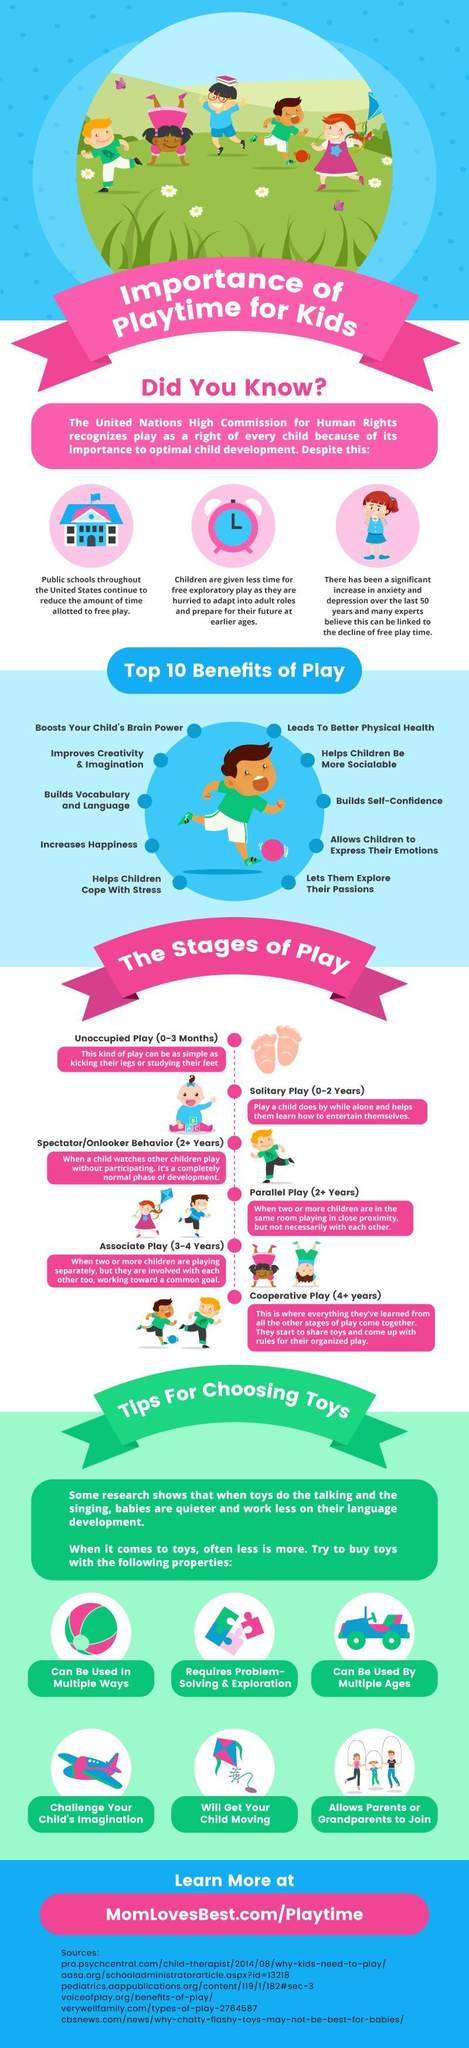What is mentioned as the fourth stage of play?
Answer the question with a short phrase. Parallel play (2+ years) What might be a reason for increase in anxiety and depression in children? decline of free play time How many stages of play are mentioned in this graphic? 6 What is the second stage of play mentioned? Solitary Play (0-2 years) What helps children be more sociable? Play 